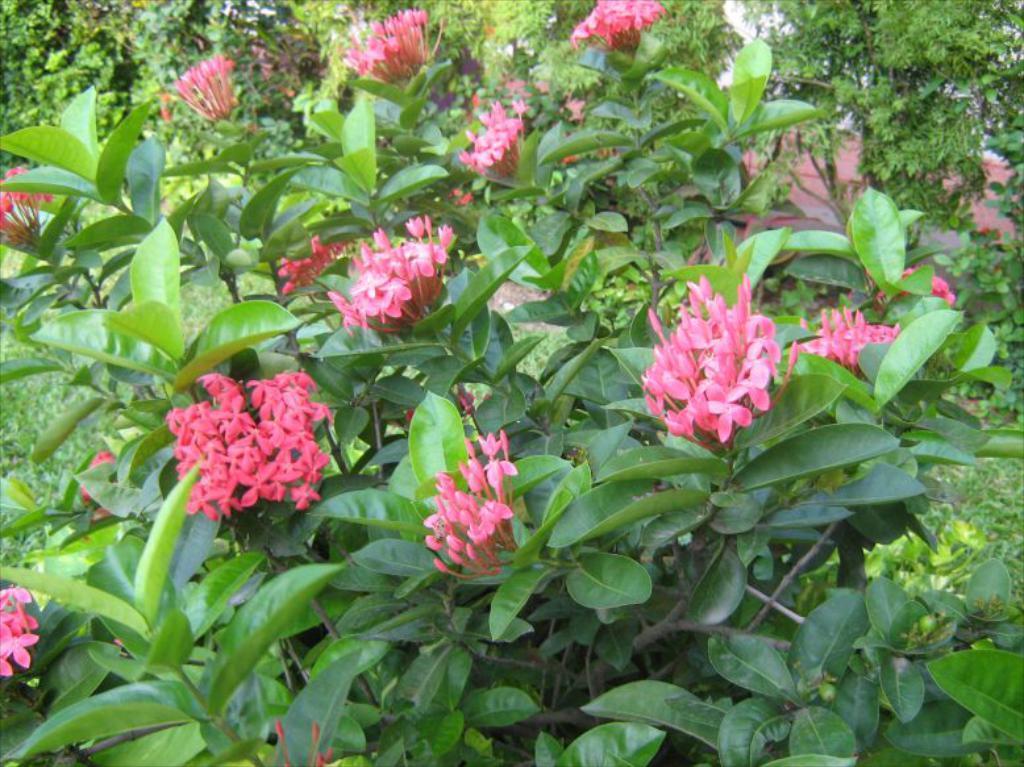Describe this image in one or two sentences. In this picture I can see the flowers on the plants. At the bottom I can see the leaves. On the right I can see the shed, trees, plants and grass. 